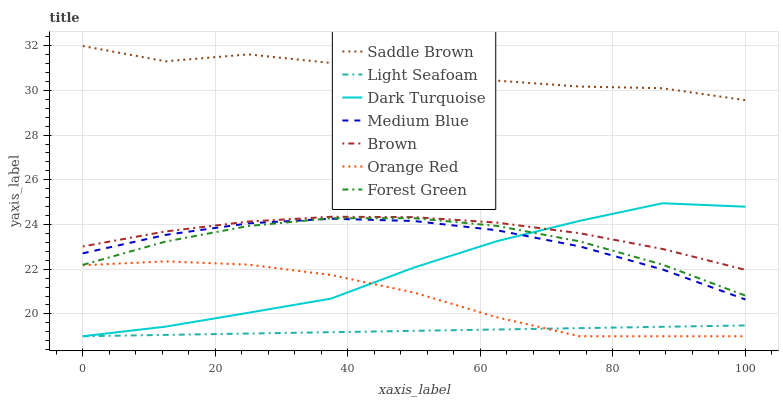Does Light Seafoam have the minimum area under the curve?
Answer yes or no. Yes. Does Saddle Brown have the maximum area under the curve?
Answer yes or no. Yes. Does Dark Turquoise have the minimum area under the curve?
Answer yes or no. No. Does Dark Turquoise have the maximum area under the curve?
Answer yes or no. No. Is Light Seafoam the smoothest?
Answer yes or no. Yes. Is Saddle Brown the roughest?
Answer yes or no. Yes. Is Dark Turquoise the smoothest?
Answer yes or no. No. Is Dark Turquoise the roughest?
Answer yes or no. No. Does Dark Turquoise have the lowest value?
Answer yes or no. Yes. Does Medium Blue have the lowest value?
Answer yes or no. No. Does Saddle Brown have the highest value?
Answer yes or no. Yes. Does Dark Turquoise have the highest value?
Answer yes or no. No. Is Forest Green less than Saddle Brown?
Answer yes or no. Yes. Is Medium Blue greater than Orange Red?
Answer yes or no. Yes. Does Dark Turquoise intersect Brown?
Answer yes or no. Yes. Is Dark Turquoise less than Brown?
Answer yes or no. No. Is Dark Turquoise greater than Brown?
Answer yes or no. No. Does Forest Green intersect Saddle Brown?
Answer yes or no. No. 